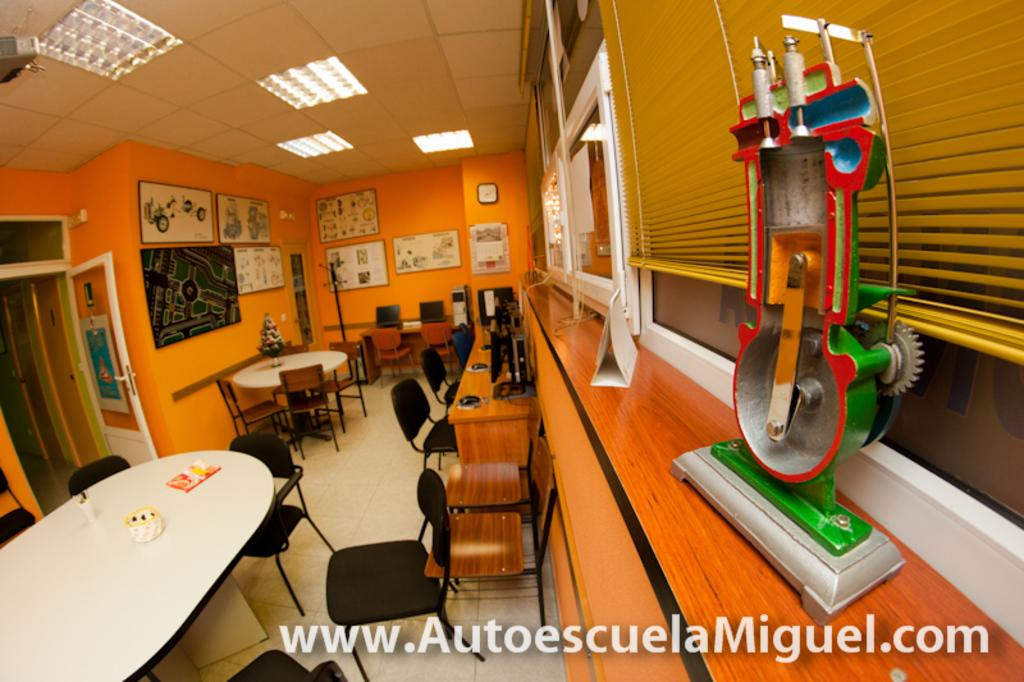What type of space is shown in the image? The image depicts a closed room. What furniture is present in the room? There are tables and chairs in the room. How can natural light enter the room? There are windows in the room through which natural light can enter. What is placed on the tables in the room? Objects are placed on the tables. What type of discovery was made in the park by the men in the image? There is no park or men present in the image; it depicts a closed room with tables, chairs, and windows. 